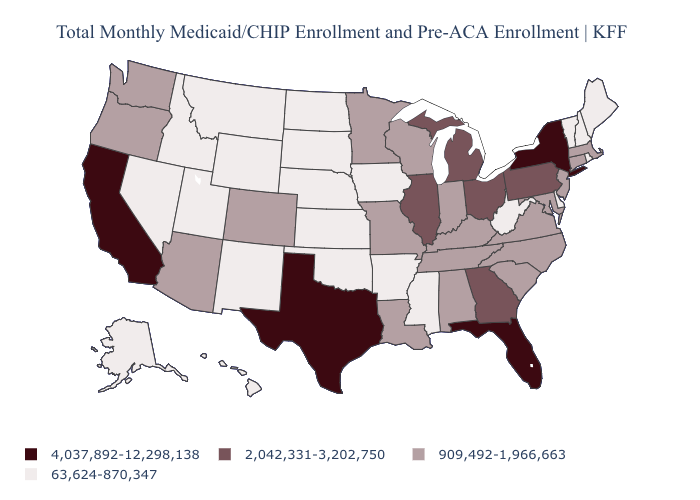Name the states that have a value in the range 4,037,892-12,298,138?
Give a very brief answer. California, Florida, New York, Texas. Does the first symbol in the legend represent the smallest category?
Quick response, please. No. Does New York have the same value as Illinois?
Be succinct. No. Name the states that have a value in the range 909,492-1,966,663?
Be succinct. Alabama, Arizona, Colorado, Connecticut, Indiana, Kentucky, Louisiana, Maryland, Massachusetts, Minnesota, Missouri, New Jersey, North Carolina, Oregon, South Carolina, Tennessee, Virginia, Washington, Wisconsin. What is the highest value in the South ?
Be succinct. 4,037,892-12,298,138. Name the states that have a value in the range 2,042,331-3,202,750?
Write a very short answer. Georgia, Illinois, Michigan, Ohio, Pennsylvania. Does South Dakota have a higher value than Virginia?
Write a very short answer. No. Does Georgia have a higher value than Arizona?
Write a very short answer. Yes. What is the highest value in the USA?
Keep it brief. 4,037,892-12,298,138. Name the states that have a value in the range 63,624-870,347?
Keep it brief. Alaska, Arkansas, Delaware, Hawaii, Idaho, Iowa, Kansas, Maine, Mississippi, Montana, Nebraska, Nevada, New Hampshire, New Mexico, North Dakota, Oklahoma, Rhode Island, South Dakota, Utah, Vermont, West Virginia, Wyoming. What is the value of Connecticut?
Be succinct. 909,492-1,966,663. Is the legend a continuous bar?
Be succinct. No. What is the highest value in the MidWest ?
Short answer required. 2,042,331-3,202,750. Does Wisconsin have a lower value than Virginia?
Write a very short answer. No. Name the states that have a value in the range 2,042,331-3,202,750?
Answer briefly. Georgia, Illinois, Michigan, Ohio, Pennsylvania. 